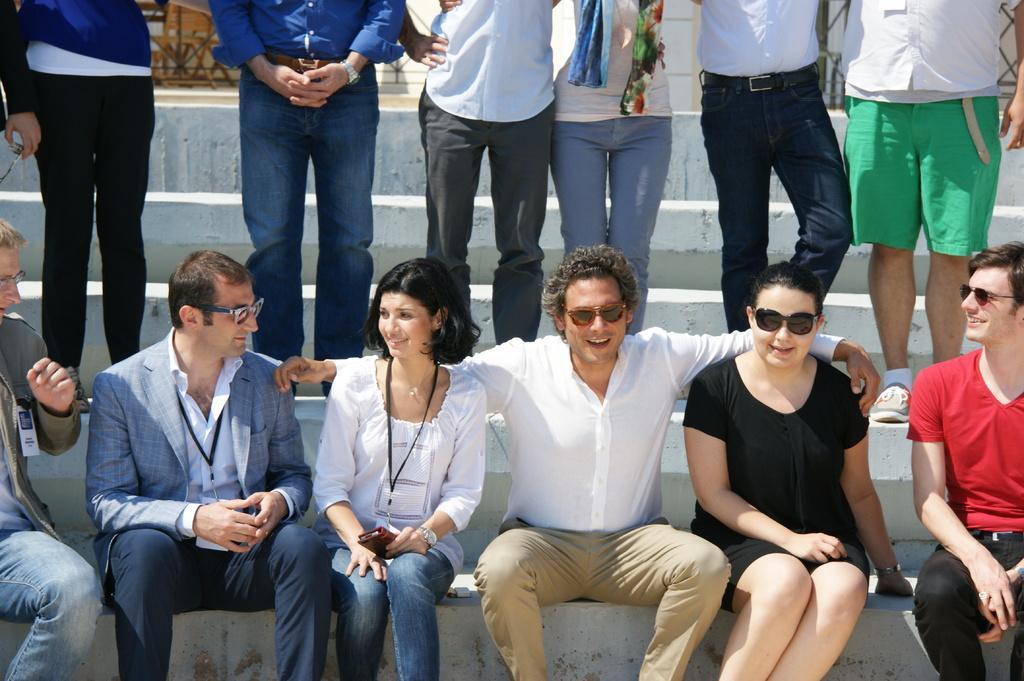In one or two sentences, can you explain what this image depicts? In the image we can see there are people sitting on the stairs and there is a woman holding mobile phone in his hand. Behind there are other people standing on the stairs. 